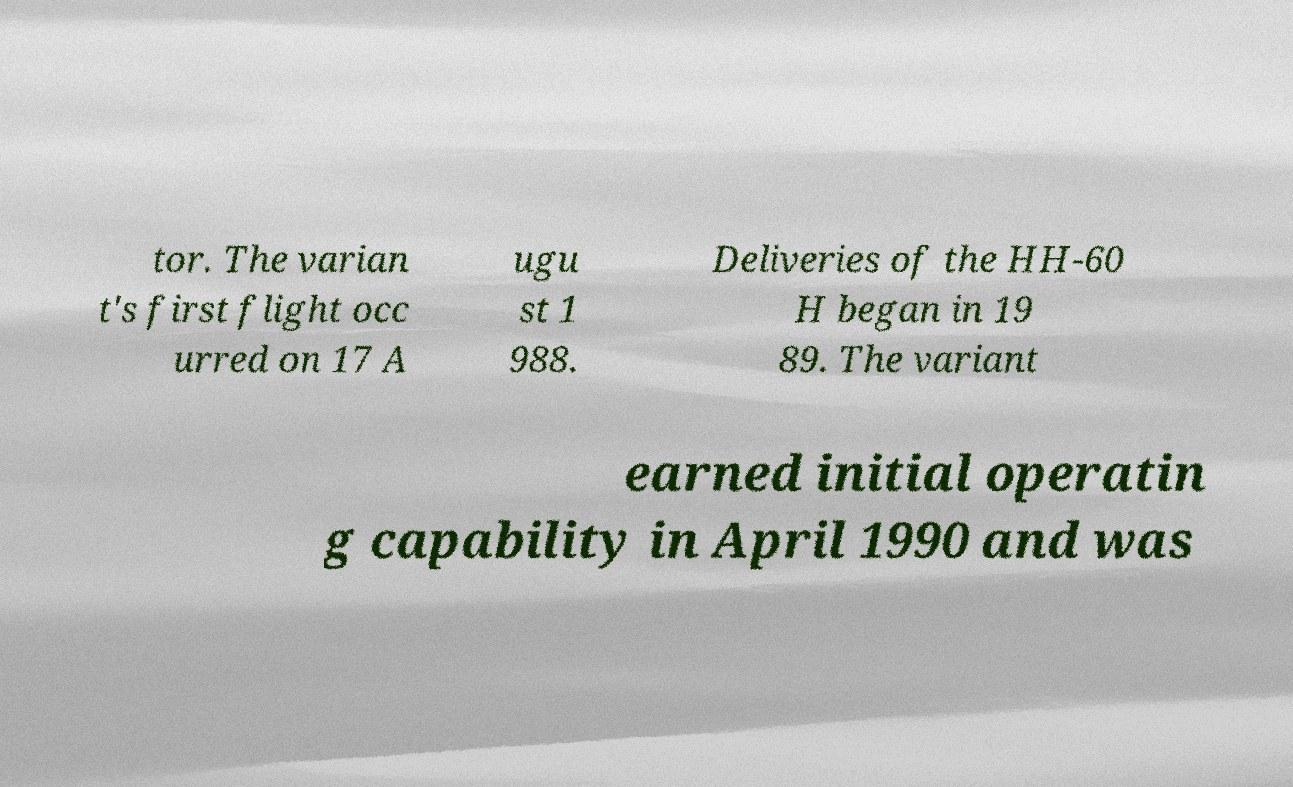Can you read and provide the text displayed in the image?This photo seems to have some interesting text. Can you extract and type it out for me? tor. The varian t's first flight occ urred on 17 A ugu st 1 988. Deliveries of the HH-60 H began in 19 89. The variant earned initial operatin g capability in April 1990 and was 